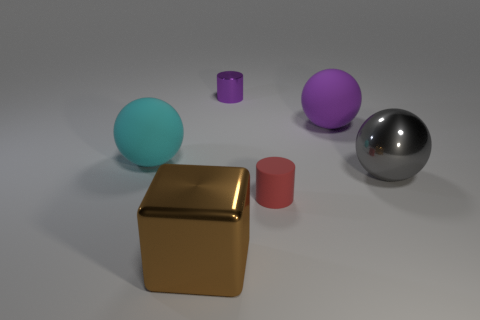Add 3 blocks. How many objects exist? 9 Subtract all cyan rubber balls. How many balls are left? 2 Subtract all blocks. How many objects are left? 5 Add 6 purple cylinders. How many purple cylinders exist? 7 Subtract all purple cylinders. How many cylinders are left? 1 Subtract 1 gray spheres. How many objects are left? 5 Subtract 1 spheres. How many spheres are left? 2 Subtract all blue blocks. Subtract all red cylinders. How many blocks are left? 1 Subtract all brown cubes. How many purple balls are left? 1 Subtract all blue objects. Subtract all rubber things. How many objects are left? 3 